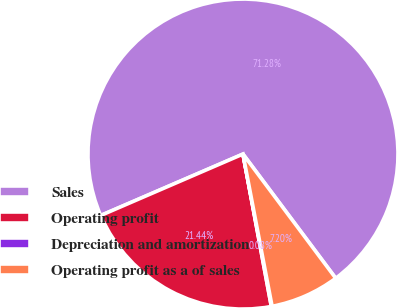Convert chart to OTSL. <chart><loc_0><loc_0><loc_500><loc_500><pie_chart><fcel>Sales<fcel>Operating profit<fcel>Depreciation and amortization<fcel>Operating profit as a of sales<nl><fcel>71.27%<fcel>21.44%<fcel>0.08%<fcel>7.2%<nl></chart> 